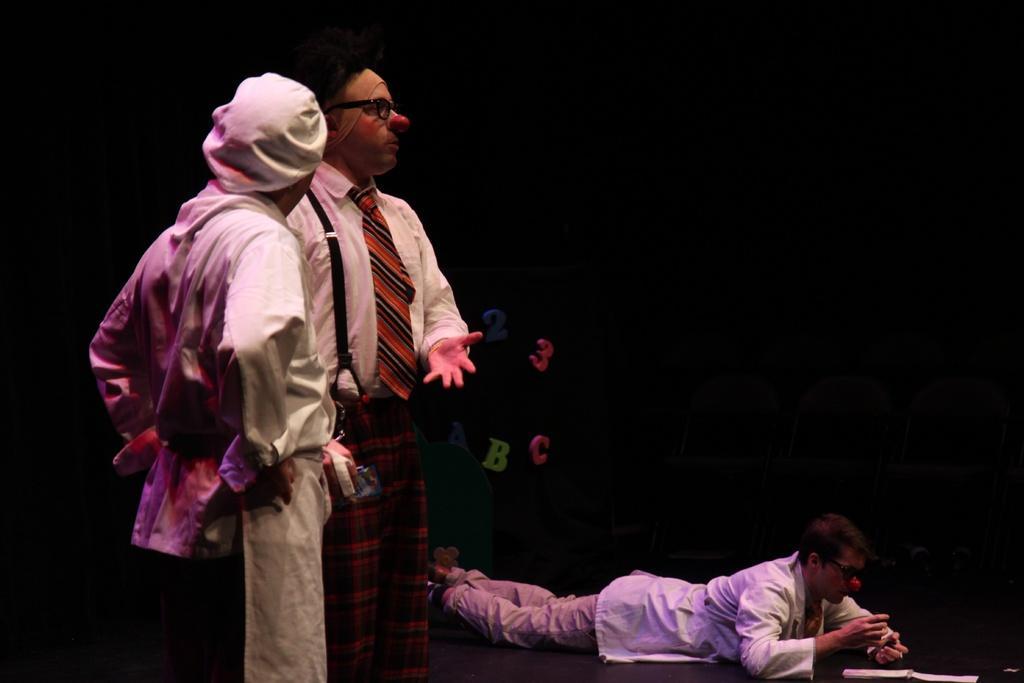Can you describe this image briefly? In this image in the front there are persons standing. In the center there is a person laying on the ground and there are papers on the ground. In the background there are numbers and alphabets visible. 